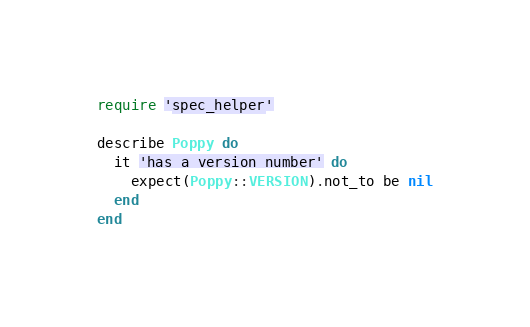<code> <loc_0><loc_0><loc_500><loc_500><_Ruby_>require 'spec_helper'

describe Poppy do
  it 'has a version number' do
    expect(Poppy::VERSION).not_to be nil
  end
end
</code> 